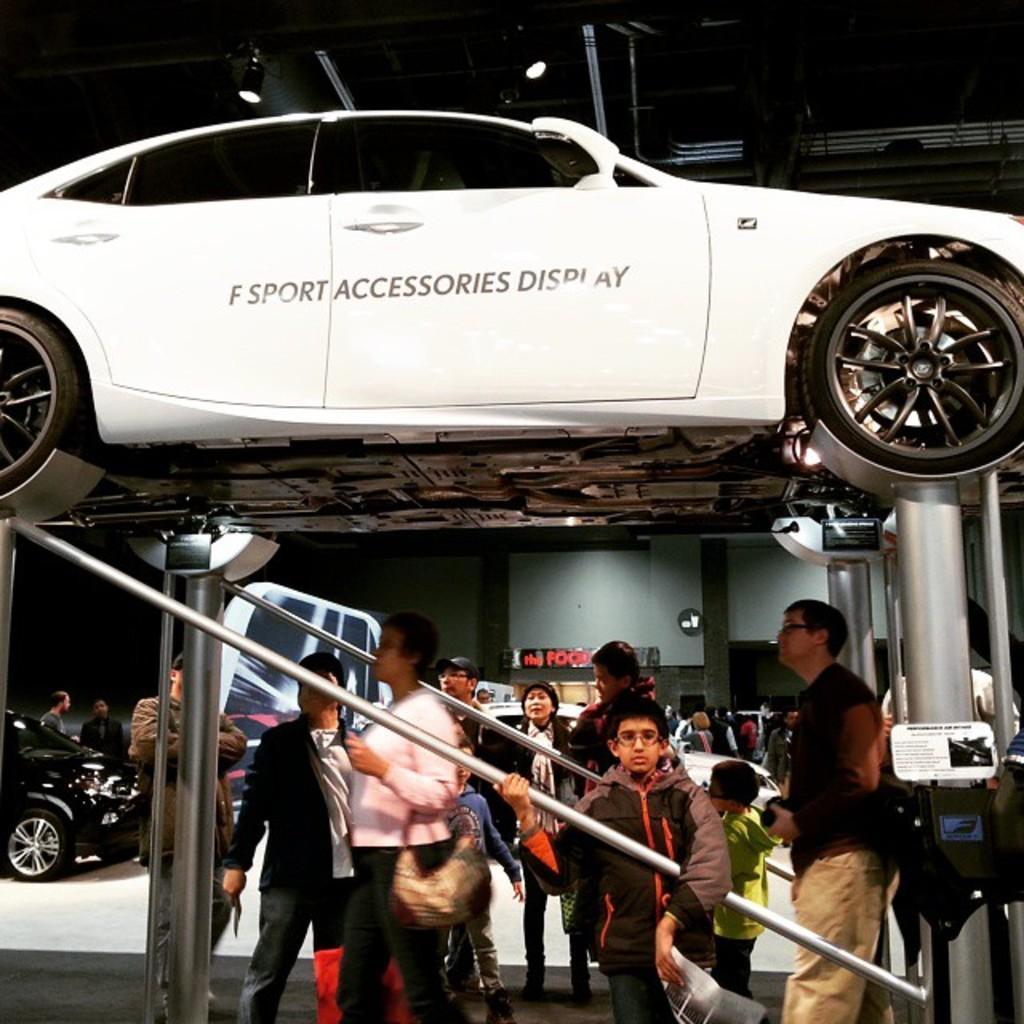Describe this image in one or two sentences. In this picture there is sports car at the top side of the image on the rods and there are people at the bottom side of the image, there are other cars in the background area of the image. 